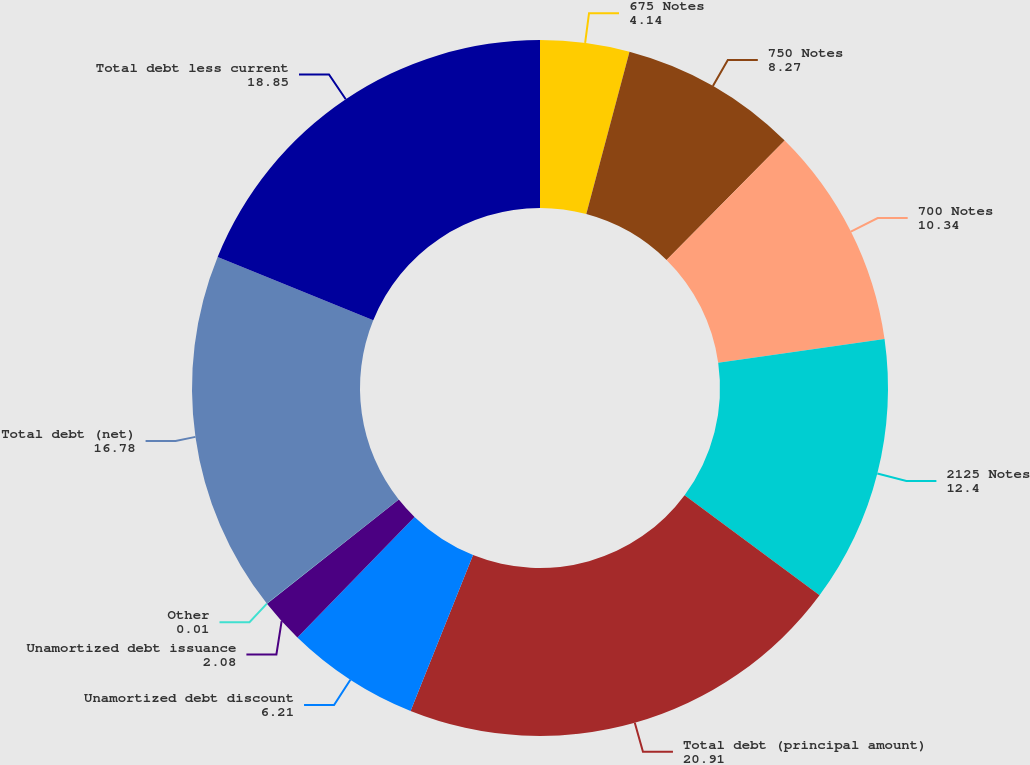Convert chart. <chart><loc_0><loc_0><loc_500><loc_500><pie_chart><fcel>675 Notes<fcel>750 Notes<fcel>700 Notes<fcel>2125 Notes<fcel>Total debt (principal amount)<fcel>Unamortized debt discount<fcel>Unamortized debt issuance<fcel>Other<fcel>Total debt (net)<fcel>Total debt less current<nl><fcel>4.14%<fcel>8.27%<fcel>10.34%<fcel>12.4%<fcel>20.91%<fcel>6.21%<fcel>2.08%<fcel>0.01%<fcel>16.78%<fcel>18.85%<nl></chart> 